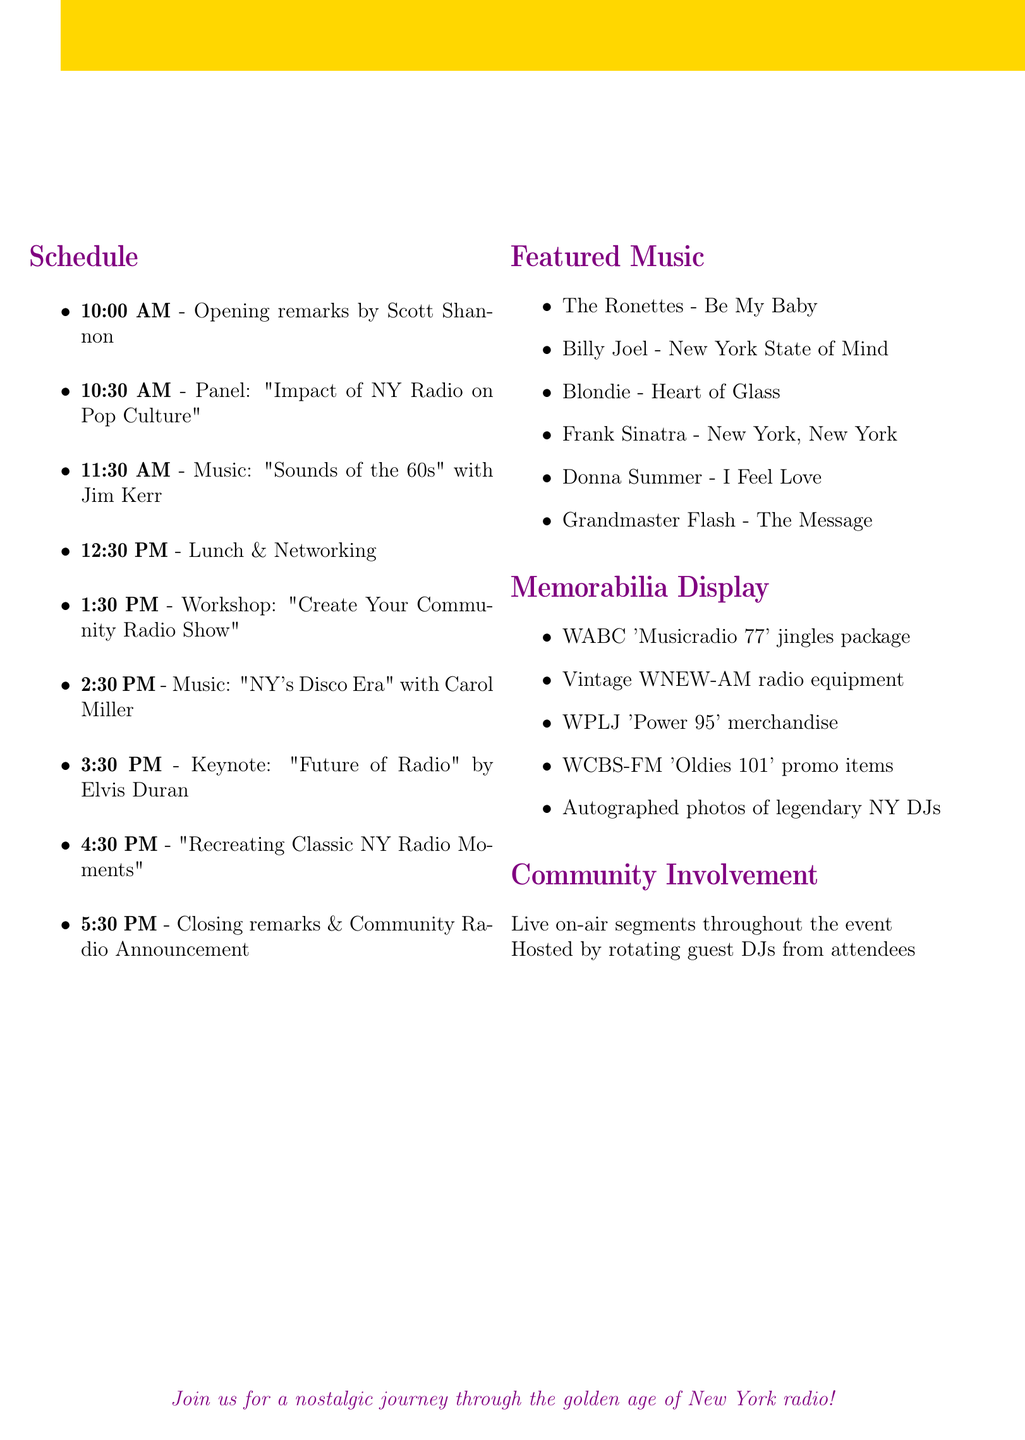What is the event name? The event name is stated at the top of the document.
Answer: New York Radio Golden Age Celebration Who is the keynote speaker? The keynote speaker is mentioned in the schedule section of the document.
Answer: Elvis Duran What time does the event start? The starting time is clearly indicated in the document's event duration section.
Answer: 10:00 AM What is the venue for the event? The venue is specified in the document.
Answer: The Cutting Room, 44 E 32nd St, New York, NY 10016 How long is the lunch break? The duration of the lunch break is mentioned in the schedule.
Answer: 1 hour Which DJ hosts the music block for 'Sounds of the 60s'? The name of the DJ is provided in the schedule for that music block.
Answer: Jim Kerr How many speakers are in the panel discussion? The number of speakers is mentioned where the panel activity is described.
Answer: Three What is the activity during the last hour of the event? The last hour's activity can be found in the scheduled list.
Answer: Closing remarks and community radio announcement What type of memorabilia will be displayed? The types of memorabilia are detailed in the memorabilia display section.
Answer: Original WABC 'Musicradio 77' jingles package 